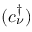<formula> <loc_0><loc_0><loc_500><loc_500>( c _ { \nu } ^ { \dagger } )</formula> 